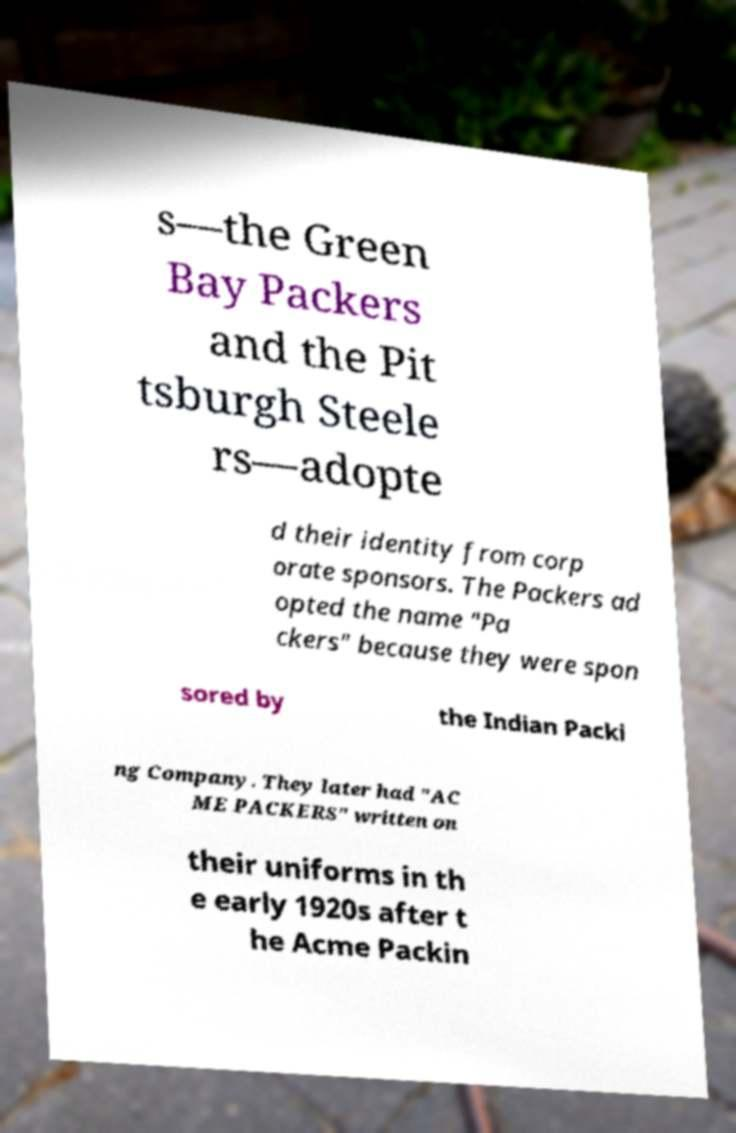Please read and relay the text visible in this image. What does it say? s—the Green Bay Packers and the Pit tsburgh Steele rs—adopte d their identity from corp orate sponsors. The Packers ad opted the name "Pa ckers" because they were spon sored by the Indian Packi ng Company. They later had "AC ME PACKERS" written on their uniforms in th e early 1920s after t he Acme Packin 